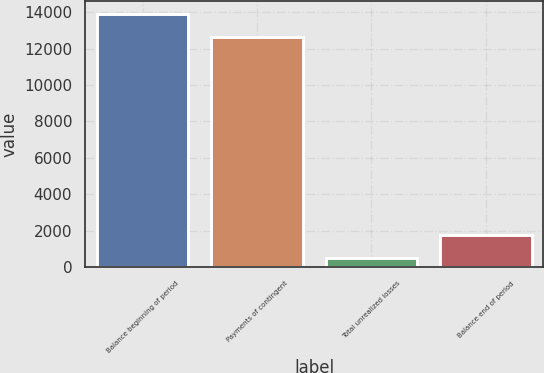Convert chart. <chart><loc_0><loc_0><loc_500><loc_500><bar_chart><fcel>Balance beginning of period<fcel>Payments of contingent<fcel>Total unrealized losses<fcel>Balance end of period<nl><fcel>13916.7<fcel>12661<fcel>513<fcel>1768.7<nl></chart> 